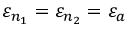<formula> <loc_0><loc_0><loc_500><loc_500>\varepsilon _ { n _ { 1 } } = \varepsilon _ { n _ { 2 } } = \varepsilon _ { a }</formula> 